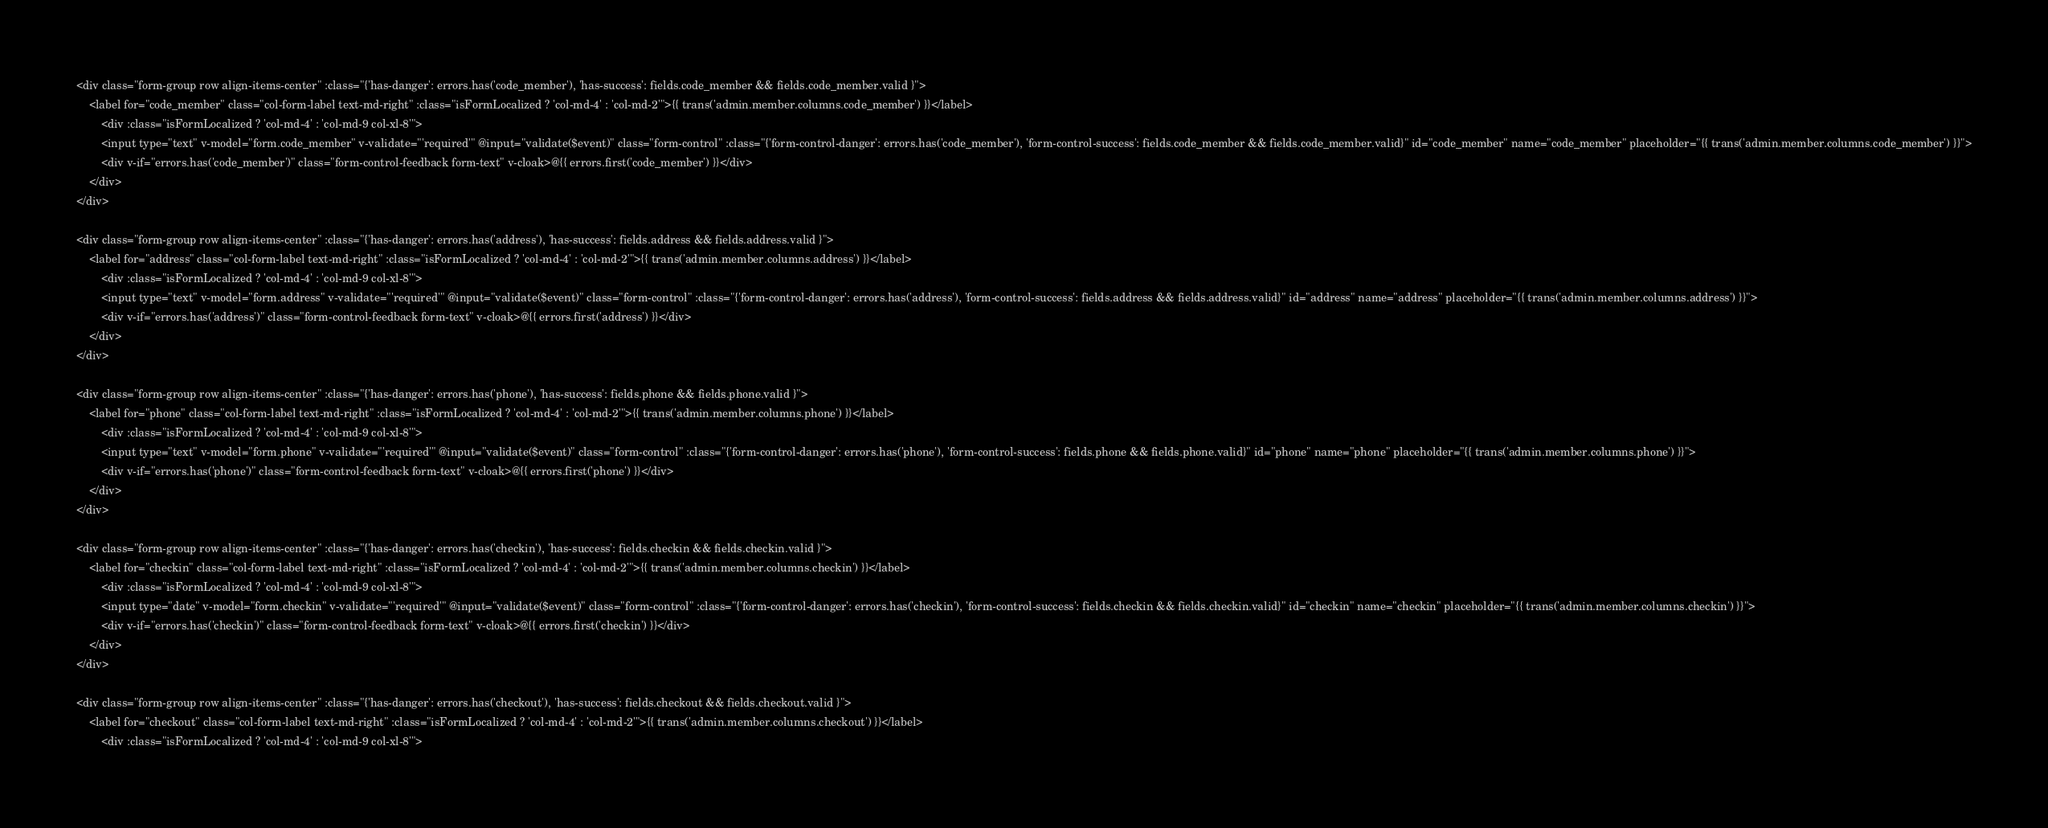Convert code to text. <code><loc_0><loc_0><loc_500><loc_500><_PHP_><div class="form-group row align-items-center" :class="{'has-danger': errors.has('code_member'), 'has-success': fields.code_member && fields.code_member.valid }">
    <label for="code_member" class="col-form-label text-md-right" :class="isFormLocalized ? 'col-md-4' : 'col-md-2'">{{ trans('admin.member.columns.code_member') }}</label>
        <div :class="isFormLocalized ? 'col-md-4' : 'col-md-9 col-xl-8'">
        <input type="text" v-model="form.code_member" v-validate="'required'" @input="validate($event)" class="form-control" :class="{'form-control-danger': errors.has('code_member'), 'form-control-success': fields.code_member && fields.code_member.valid}" id="code_member" name="code_member" placeholder="{{ trans('admin.member.columns.code_member') }}">
        <div v-if="errors.has('code_member')" class="form-control-feedback form-text" v-cloak>@{{ errors.first('code_member') }}</div>
    </div>
</div>

<div class="form-group row align-items-center" :class="{'has-danger': errors.has('address'), 'has-success': fields.address && fields.address.valid }">
    <label for="address" class="col-form-label text-md-right" :class="isFormLocalized ? 'col-md-4' : 'col-md-2'">{{ trans('admin.member.columns.address') }}</label>
        <div :class="isFormLocalized ? 'col-md-4' : 'col-md-9 col-xl-8'">
        <input type="text" v-model="form.address" v-validate="'required'" @input="validate($event)" class="form-control" :class="{'form-control-danger': errors.has('address'), 'form-control-success': fields.address && fields.address.valid}" id="address" name="address" placeholder="{{ trans('admin.member.columns.address') }}">
        <div v-if="errors.has('address')" class="form-control-feedback form-text" v-cloak>@{{ errors.first('address') }}</div>
    </div>
</div>

<div class="form-group row align-items-center" :class="{'has-danger': errors.has('phone'), 'has-success': fields.phone && fields.phone.valid }">
    <label for="phone" class="col-form-label text-md-right" :class="isFormLocalized ? 'col-md-4' : 'col-md-2'">{{ trans('admin.member.columns.phone') }}</label>
        <div :class="isFormLocalized ? 'col-md-4' : 'col-md-9 col-xl-8'">
        <input type="text" v-model="form.phone" v-validate="'required'" @input="validate($event)" class="form-control" :class="{'form-control-danger': errors.has('phone'), 'form-control-success': fields.phone && fields.phone.valid}" id="phone" name="phone" placeholder="{{ trans('admin.member.columns.phone') }}">
        <div v-if="errors.has('phone')" class="form-control-feedback form-text" v-cloak>@{{ errors.first('phone') }}</div>
    </div>
</div>

<div class="form-group row align-items-center" :class="{'has-danger': errors.has('checkin'), 'has-success': fields.checkin && fields.checkin.valid }">
    <label for="checkin" class="col-form-label text-md-right" :class="isFormLocalized ? 'col-md-4' : 'col-md-2'">{{ trans('admin.member.columns.checkin') }}</label>
        <div :class="isFormLocalized ? 'col-md-4' : 'col-md-9 col-xl-8'">
        <input type="date" v-model="form.checkin" v-validate="'required'" @input="validate($event)" class="form-control" :class="{'form-control-danger': errors.has('checkin'), 'form-control-success': fields.checkin && fields.checkin.valid}" id="checkin" name="checkin" placeholder="{{ trans('admin.member.columns.checkin') }}">
        <div v-if="errors.has('checkin')" class="form-control-feedback form-text" v-cloak>@{{ errors.first('checkin') }}</div>
    </div>
</div>

<div class="form-group row align-items-center" :class="{'has-danger': errors.has('checkout'), 'has-success': fields.checkout && fields.checkout.valid }">
    <label for="checkout" class="col-form-label text-md-right" :class="isFormLocalized ? 'col-md-4' : 'col-md-2'">{{ trans('admin.member.columns.checkout') }}</label>
        <div :class="isFormLocalized ? 'col-md-4' : 'col-md-9 col-xl-8'"></code> 